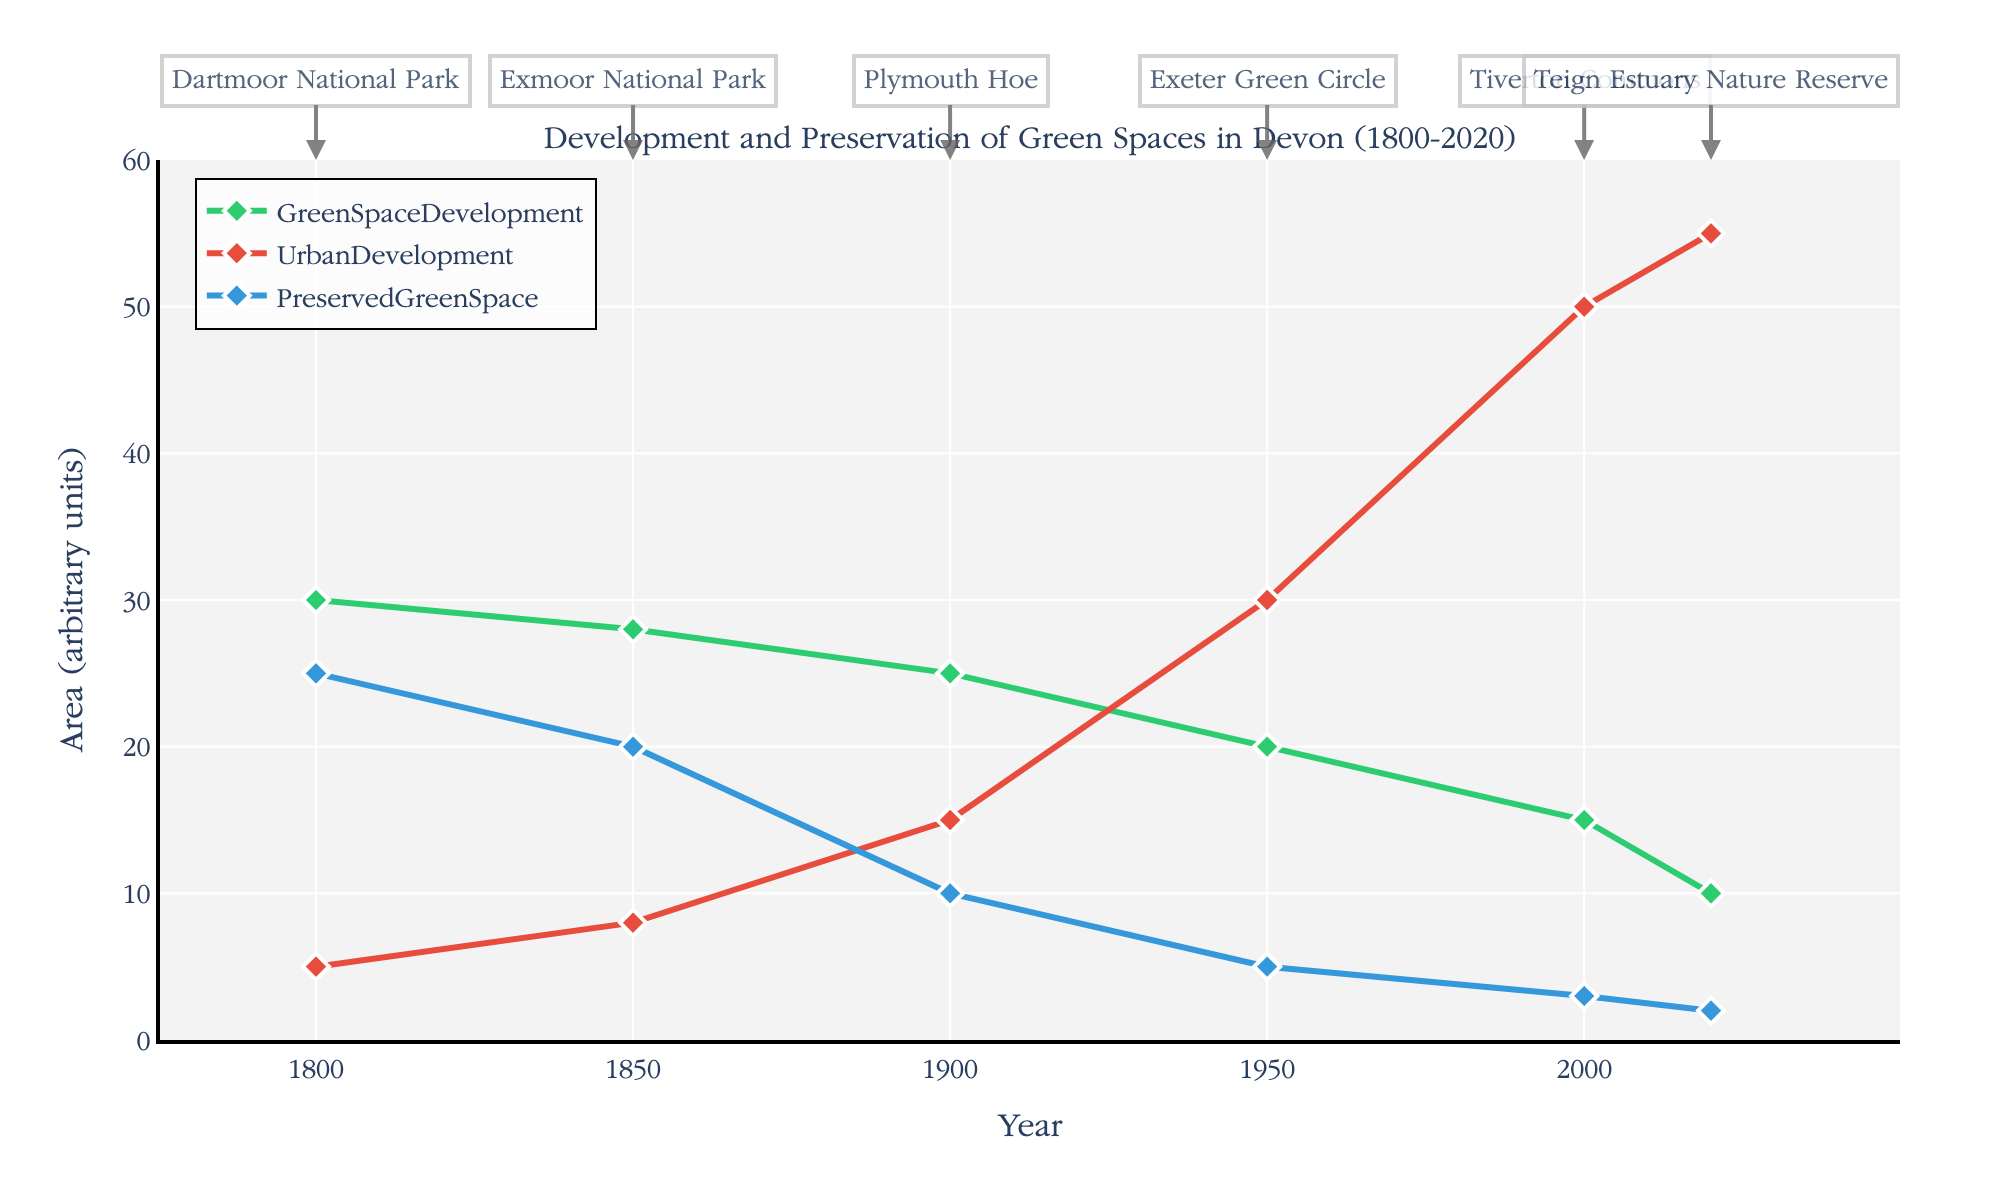what is the title of the figure? The title is at the top of the figure and provides a clear description of the data being presented.
Answer: Development and Preservation of Green Spaces in Devon (1800-2020) How does urban development change from 1800 to 2020? Look at the red line representing the urban development. Compare its values at 1800 and 2020; the increase is noticeable.
Answer: It increases from 5 to 55 Which year shows the highest amount of preserved green space? Look for the blue line, which represents preserved green space. Identify the peak of this line which is visible around 1800.
Answer: 1800 What notable site is annotated for the year 2000? Check the annotation on the figure around the year 2000; notable sites are marked with text.
Answer: Tiverton Commons Between 1900 and 1950, how does the preserved green space change? Compare the blue line values at 1900 (10) and 1950 (5); calculate the difference.
Answer: It decreases by 5 units What is the average urban development from 1800 to 2020? Sum the urban development values at each time point and divide by the number of points: (5 + 8 + 15 + 30 + 50 + 55) / 6.
Answer: 27.17 In which period did green space development decline the most? Observe the green line and note its values. The largest drop appears between 1950 (20) and 2000 (15).
Answer: 1950 to 2000 What color represents GreenSpaceDevelopment in the plot? Refer to the legend and the corresponding line colors in the plot.
Answer: Green Is the preserved green space trend increasing or decreasing over time? Look at the blue line from 1800 to 2020 and note its downward trajectory.
Answer: Decreasing Compare urban development in 1850 and 2000. Which year has higher urban development? Check the red line values at 1850 and 2000; 2000 has a higher value of 50 compared to 8 in 1850.
Answer: 2000 